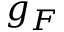Convert formula to latex. <formula><loc_0><loc_0><loc_500><loc_500>g _ { F }</formula> 